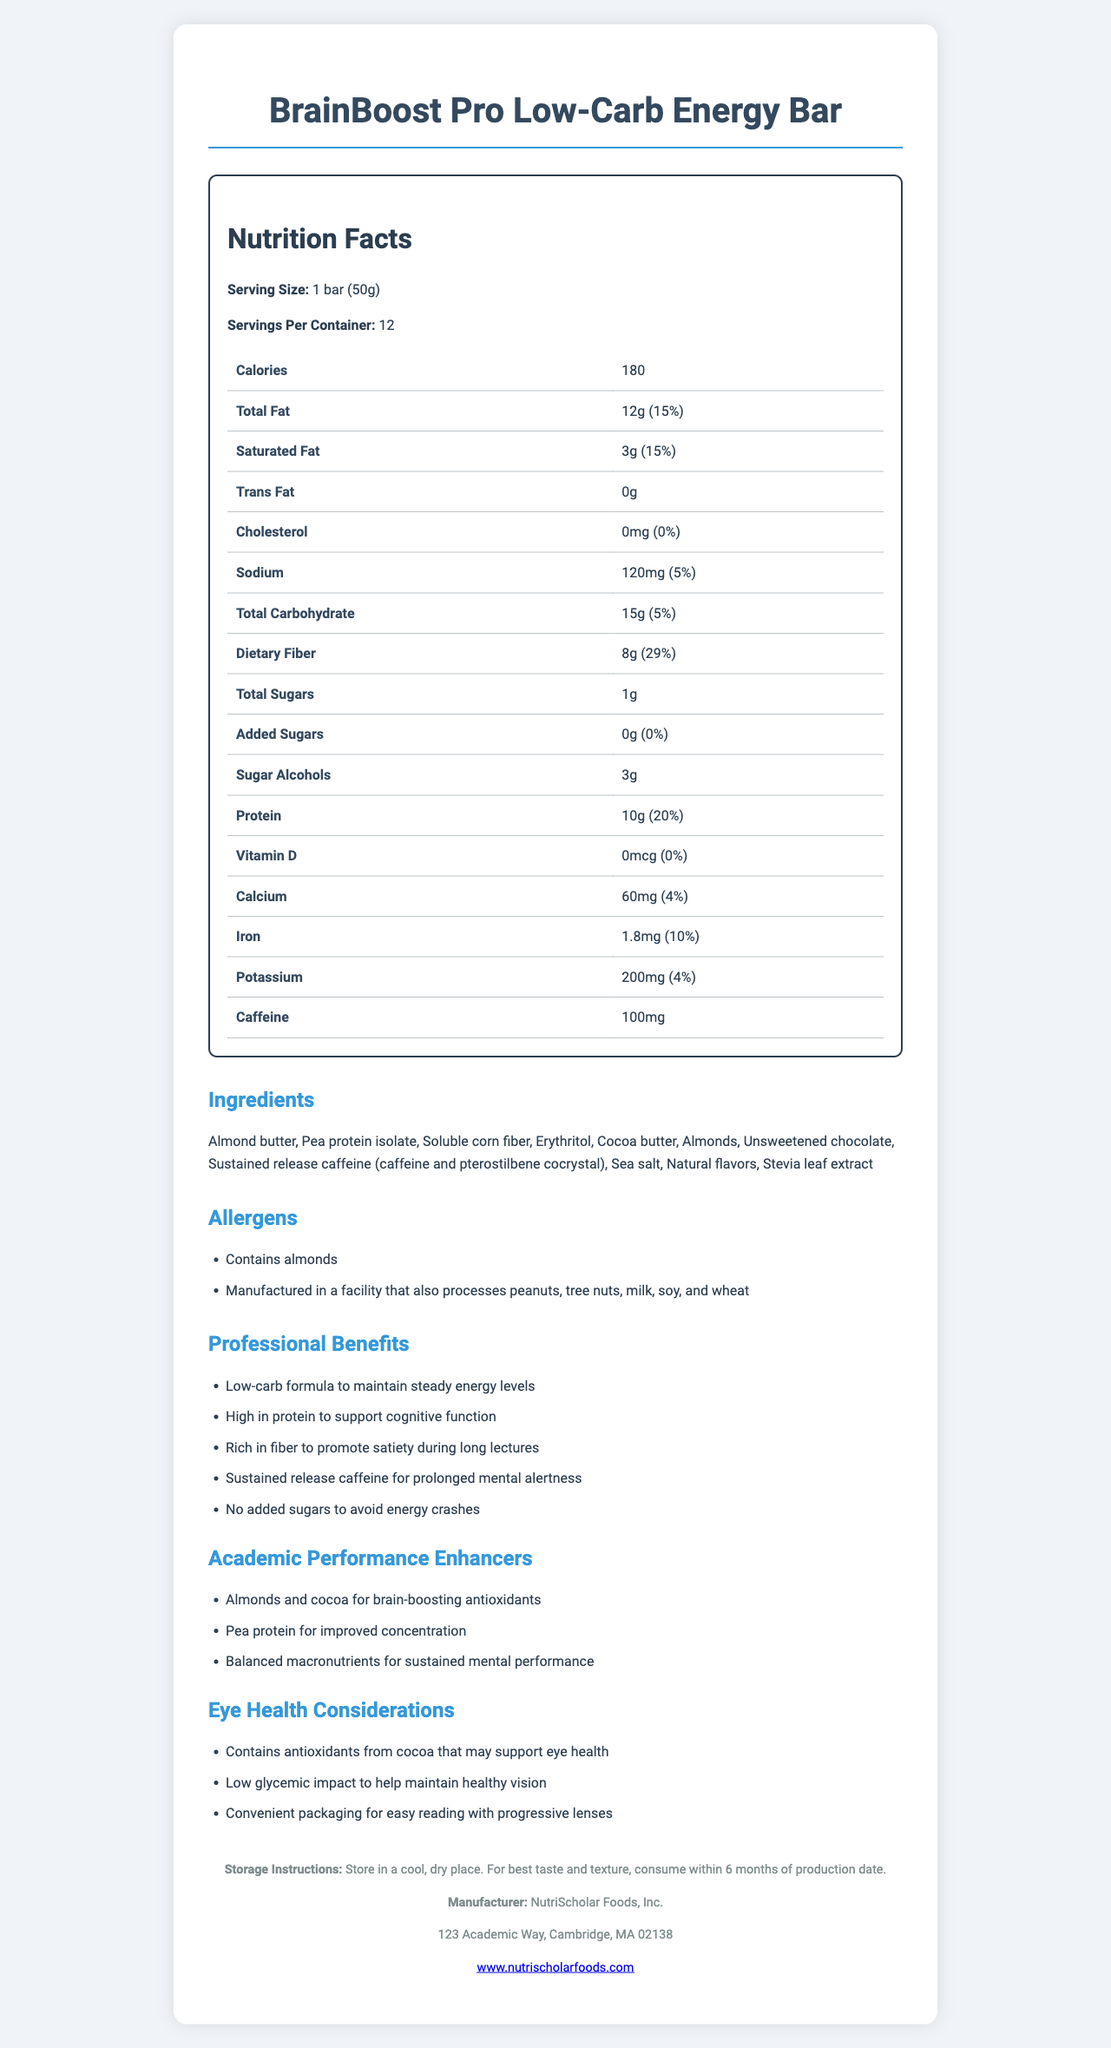who is the manufacturer of BrainBoost Pro Low-Carb Energy Bar? The manufacturer information is provided at the bottom of the document, indicating the name "NutriScholar Foods, Inc."
Answer: NutriScholar Foods, Inc. what is the serving size for BrainBoost Pro Low-Carb Energy Bar? The serving size is explicitly mentioned at the top of the Nutrition Facts section.
Answer: 1 bar (50g) how many grams of dietary fiber are in one serving of this energy bar? The amount of dietary fiber per serving is listed in the Nutrition Facts table under "Total Carbohydrate."
Answer: 8g how much caffeine does one bar contain? The document specifies that each bar contains 100mg of caffeine.
Answer: 100mg what are the first three ingredients listed for this product? The ingredients are listed in the document, and the first three are Almond butter, Pea protein isolate, and Soluble corn fiber.
Answer: Almond butter, Pea protein isolate, Soluble corn fiber what is the daily value percentage of protein in one serving? The daily value percentage for protein is listed in the Nutrition Facts table.
Answer: 20% which of the following ingredients is used as a sugar substitute in this energy bar? A. Sucralose B. Erythritol C. Aspartame D. Saccharin Erythritol is listed among the ingredients, indicating it is used as a sugar substitute.
Answer: B which nutrient has the highest daily value percentage in one serving of this bar? I. Iron II. Dietary Fiber III. Protein IV. Sodium Dietary Fiber has a daily value of 29%, which is the highest among the listed nutrients.
Answer: II does this energy bar contain any Vitamin D? The Nutrition Facts table indicates that the bar contains 0mcg of Vitamin D, which is 0% of the daily value.
Answer: No is this product suitable for someone who is allergic to almonds? The allergen information states that the product contains almonds.
Answer: No summarize the main benefits of the BrainBoost Pro Low-Carb Energy Bar for busy professionals. The document outlines various professional benefits and academic performance enhancers provided by the bar, particularly focusing on energy stabilization, cognitive support, and mental alertness.
Answer: The BrainBoost Pro Low-Carb Energy Bar is designed for busy professionals and provides several benefits such as maintaining steady energy levels, supporting cognitive function with high protein content, promoting satiety with rich fiber, offering prolonged mental alertness through sustained release caffeine, and avoiding energy crashes by containing no added sugars. how long should the BrainBoost Pro Low-Carb Energy Bar be stored to maintain best taste and texture? While the document mentions "*consume within 6 months of production date,*" the specific production date is not provided, making it unclear how long it has been since production.
Answer: Cannot be determined 